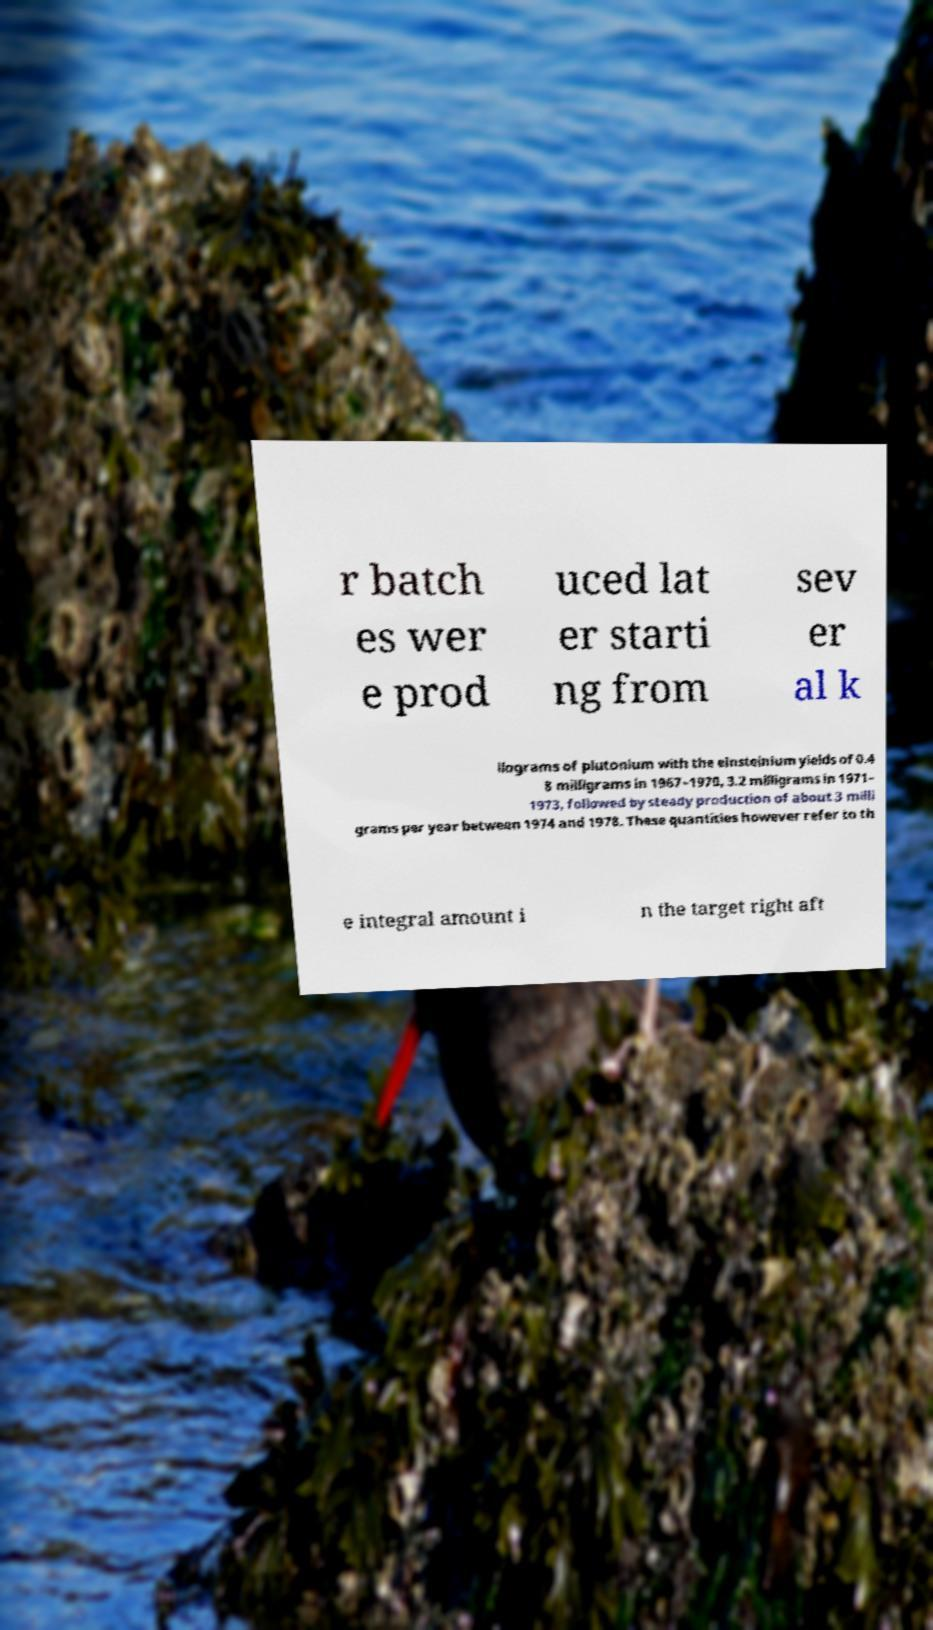I need the written content from this picture converted into text. Can you do that? r batch es wer e prod uced lat er starti ng from sev er al k ilograms of plutonium with the einsteinium yields of 0.4 8 milligrams in 1967–1970, 3.2 milligrams in 1971– 1973, followed by steady production of about 3 milli grams per year between 1974 and 1978. These quantities however refer to th e integral amount i n the target right aft 